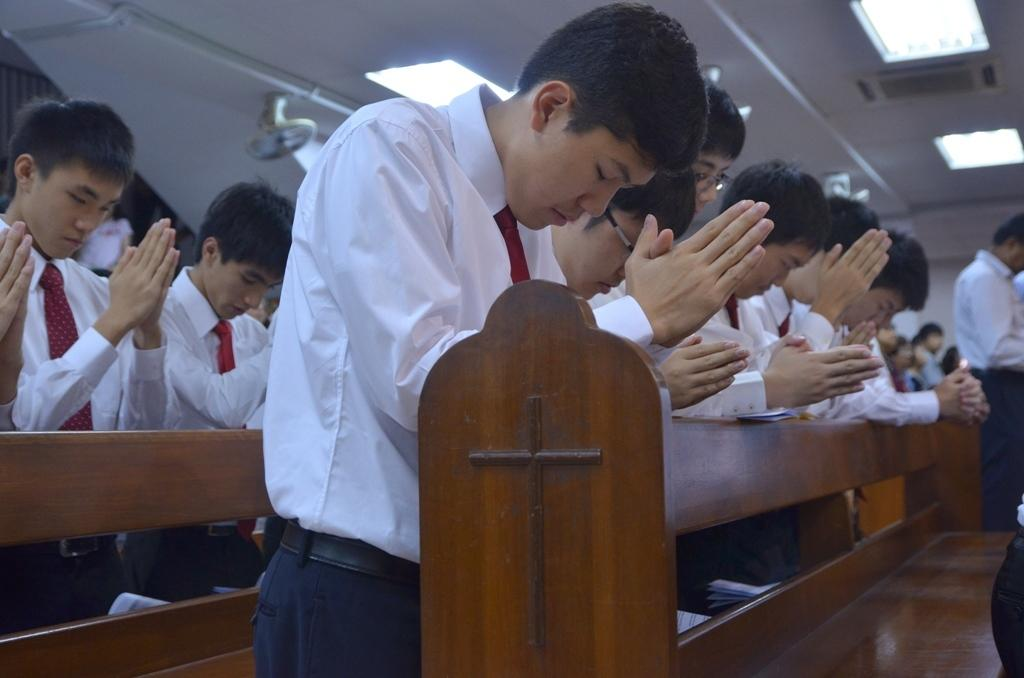What can be seen in the image involving people? There are people standing in the image. What type of seating is present in the image? There are benches in the image. What structure is visible in the image that provides shelter? There is a roof visible in the image. What type of illumination is present in the image? There are lights in the image. What type of wrench is being used by the people in the image? There is no wrench present in the image; the people are simply standing. Who is the owner of the benches in the image? The image does not provide information about the ownership of the benches, so it cannot be determined. 